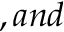<formula> <loc_0><loc_0><loc_500><loc_500>, a n d</formula> 